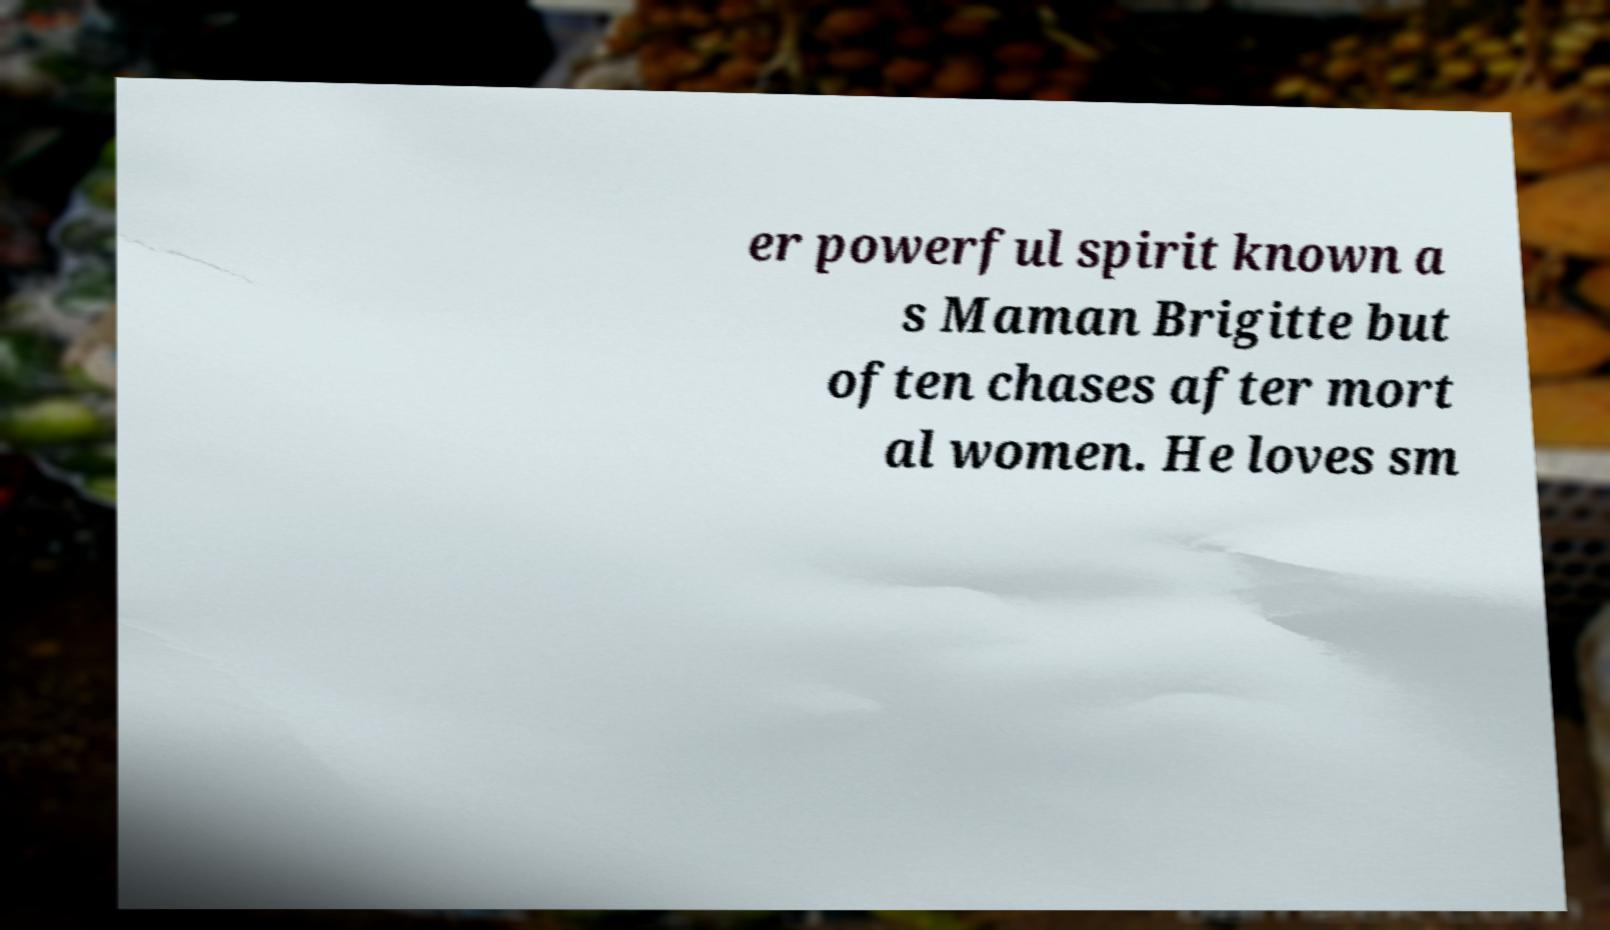Please identify and transcribe the text found in this image. er powerful spirit known a s Maman Brigitte but often chases after mort al women. He loves sm 